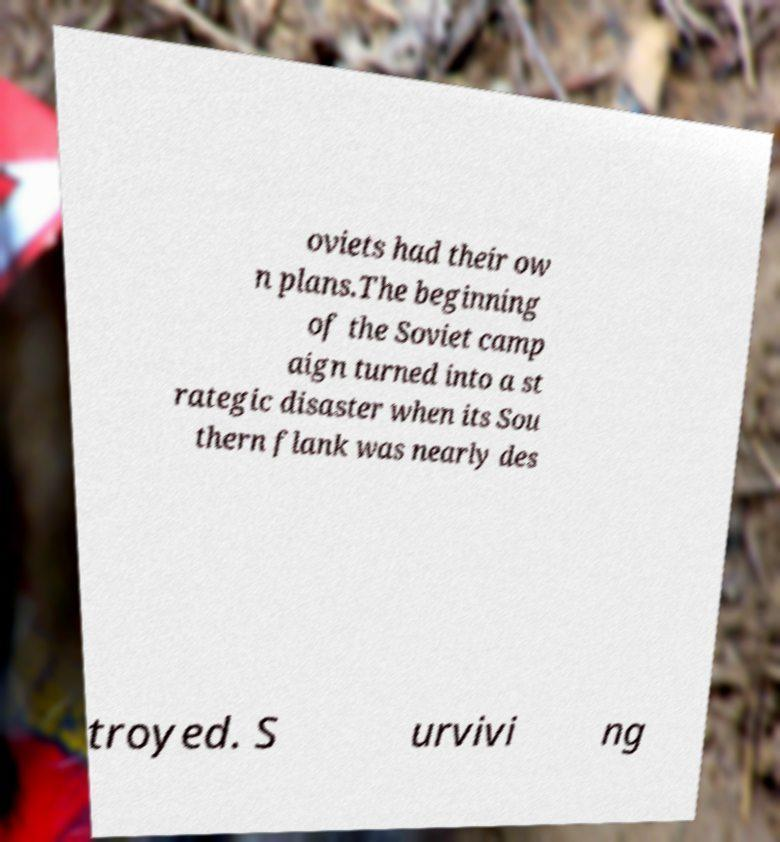Could you assist in decoding the text presented in this image and type it out clearly? oviets had their ow n plans.The beginning of the Soviet camp aign turned into a st rategic disaster when its Sou thern flank was nearly des troyed. S urvivi ng 